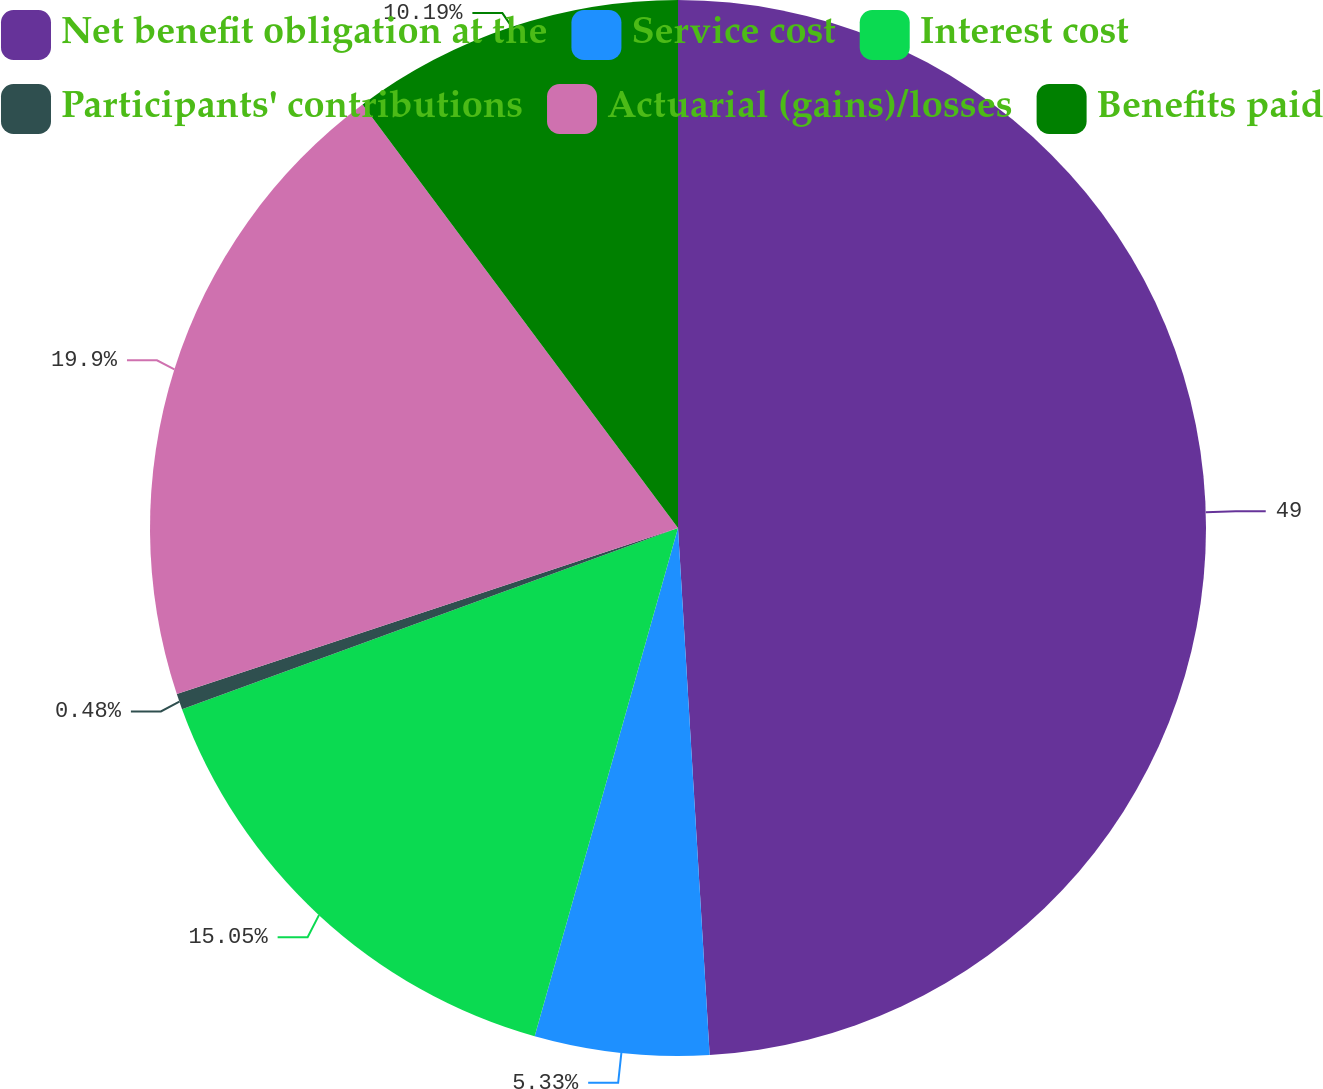Convert chart to OTSL. <chart><loc_0><loc_0><loc_500><loc_500><pie_chart><fcel>Net benefit obligation at the<fcel>Service cost<fcel>Interest cost<fcel>Participants' contributions<fcel>Actuarial (gains)/losses<fcel>Benefits paid<nl><fcel>49.04%<fcel>5.33%<fcel>15.05%<fcel>0.48%<fcel>19.9%<fcel>10.19%<nl></chart> 